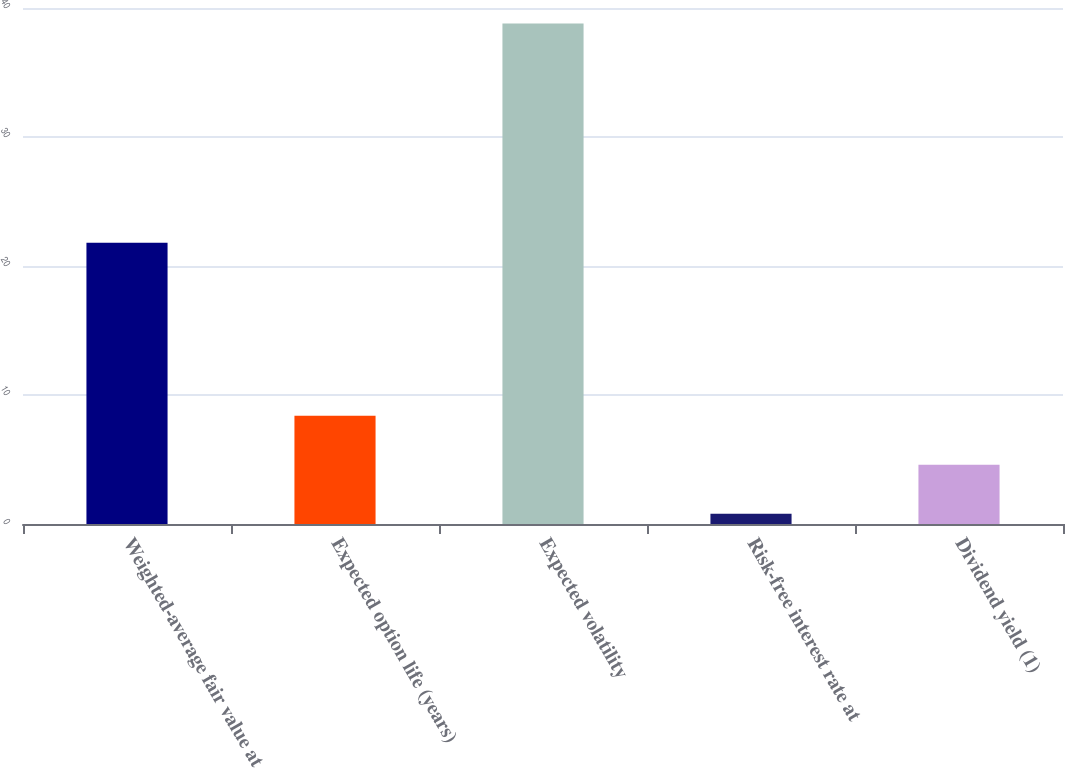Convert chart to OTSL. <chart><loc_0><loc_0><loc_500><loc_500><bar_chart><fcel>Weighted-average fair value at<fcel>Expected option life (years)<fcel>Expected volatility<fcel>Risk-free interest rate at<fcel>Dividend yield (1)<nl><fcel>21.8<fcel>8.4<fcel>38.8<fcel>0.8<fcel>4.6<nl></chart> 